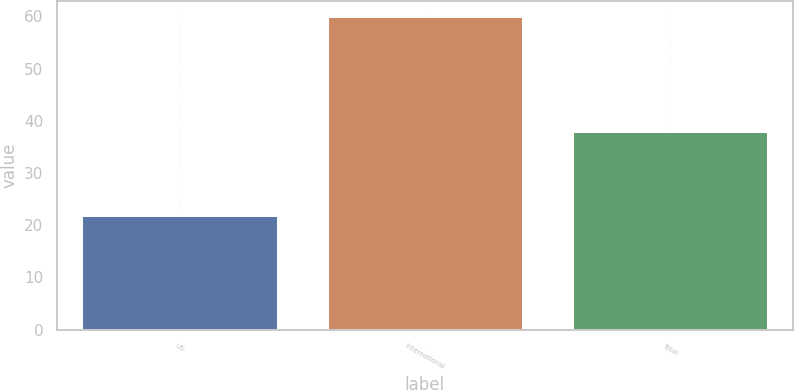<chart> <loc_0><loc_0><loc_500><loc_500><bar_chart><fcel>US<fcel>International<fcel>Total<nl><fcel>22<fcel>60<fcel>38<nl></chart> 